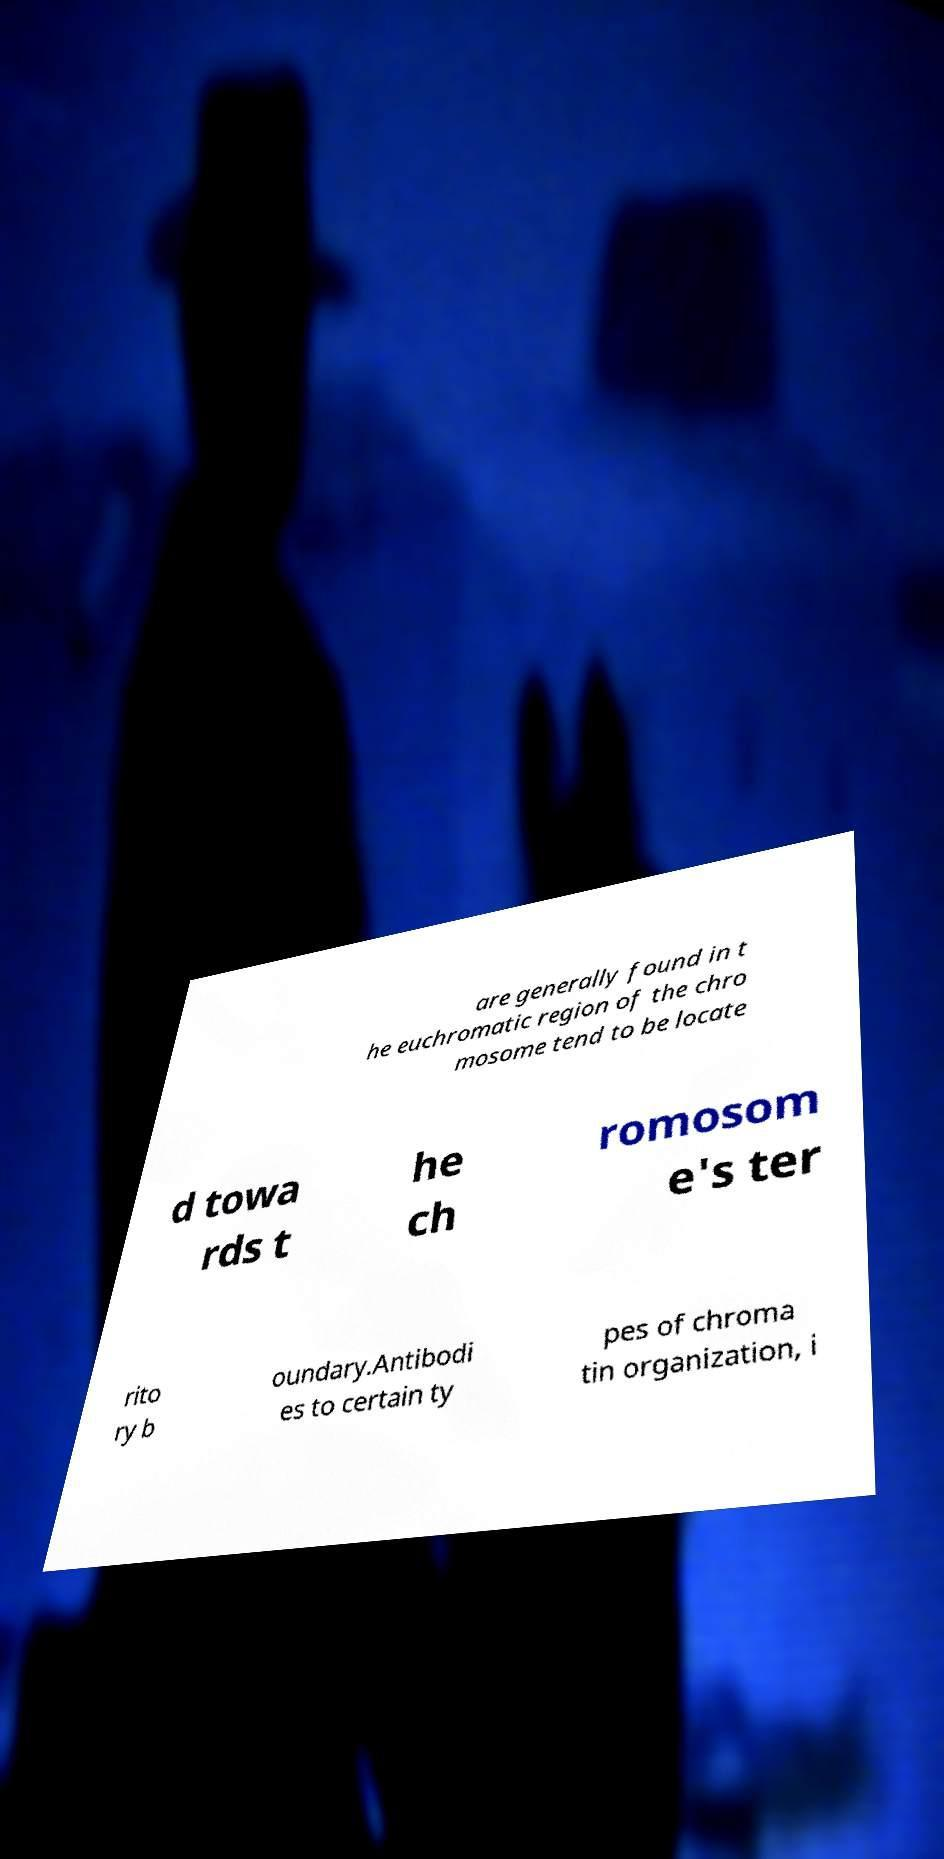Can you read and provide the text displayed in the image?This photo seems to have some interesting text. Can you extract and type it out for me? are generally found in t he euchromatic region of the chro mosome tend to be locate d towa rds t he ch romosom e's ter rito ry b oundary.Antibodi es to certain ty pes of chroma tin organization, i 